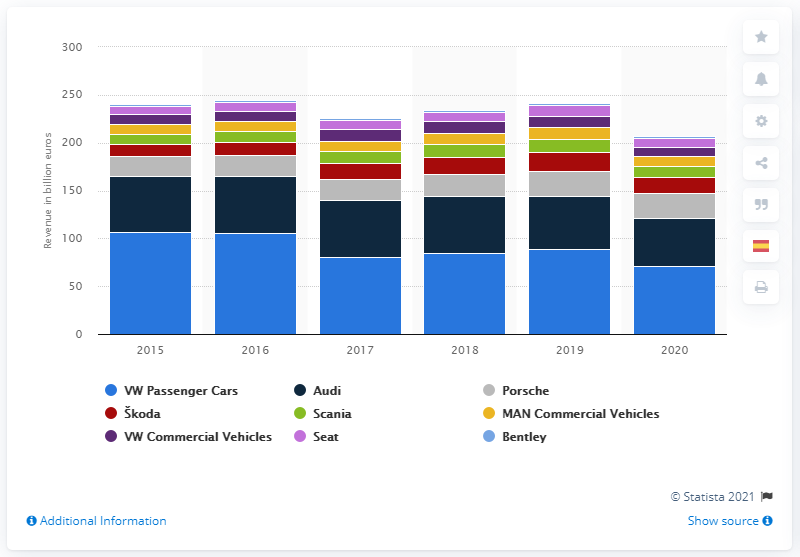Indicate a few pertinent items in this graphic. In the 2020 fiscal year, Porsche generated a total revenue of 26.06 billion euros. 